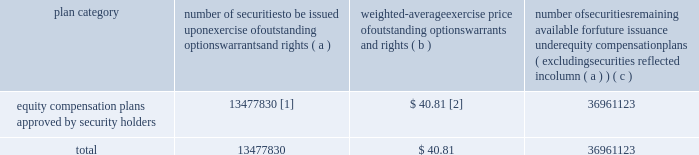Item 12 .
Security ownership of certain beneficial owners and management and related stockholder matters information as to the number of shares of our equity securities beneficially owned by each of our directors and nominees for director , our named executive officers , our directors and executive officers as a group , and certain beneficial owners is set forth in the security ownership of certain beneficial owners and management segment of the proxy statement and is incorporated herein by reference .
The table summarizes the equity compensation plans under which union pacific corporation common stock may be issued as of december 31 , 2008 .
Number of securities to be issued upon exercise of outstanding options , warrants and rights weighted-average exercise price of outstanding options , warrants and rights number of securities remaining available for future issuance under equity compensation plans ( excluding securities reflected in column ( a ) ) plan category ( a ) ( b ) ( c ) equity compensation plans approved by security holders 13477830 [1] $ 40.81 [2] 36961123 .
[1] includes 1494925 retention units that do not have an exercise price .
Does not include 1419554 retention shares that are actually issued and outstanding .
[2] does not include the retention units or retention shares described above in footnote [1] .
Item 13 .
Certain relationships and related transactions and director independence information on related transactions is set forth in the certain relationships and related transactions and compensation committee interlocks and insider participation segments of the proxy statement and is incorporated herein by reference .
We do not have any relationship with any outside third party that would enable such a party to negotiate terms of a material transaction that may not be available to , or available from , other parties on an arm 2019s-length basis .
Information regarding the independence of our directors is set forth in the director independence segment of the proxy statement and is incorporated herein by reference .
Item 14 .
Principal accountant fees and services information concerning the fees billed by our independent registered public accounting firm and the nature of services comprising the fees for each of the two most recent fiscal years in each of the following categories : ( i ) audit fees , ( ii ) audit-related fees , ( iii ) tax fees , and ( iv ) all other fees , is set forth in the independent registered public accounting firm 2019s fees and services segment of the proxy statement and is incorporated herein by reference .
Information concerning our audit committee 2019s policies and procedures pertaining to pre-approval of audit and non-audit services rendered by our independent registered public accounting firm is set forth in the audit committee segment of the proxy statement and is incorporated herein by reference. .
As of december 31 , 2008 what was the percent of the number of securities to be issued upon exercise of outstanding options warrants and rights that did not have an exercise price? 
Computations: (1494925 / 13477830)
Answer: 0.11092. 